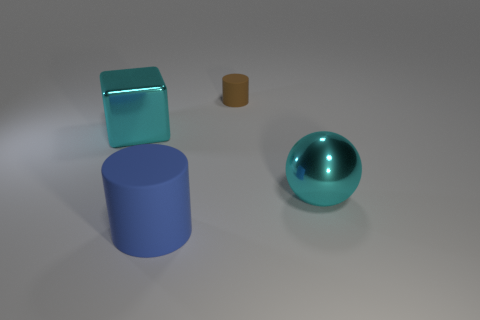Add 3 small green shiny cylinders. How many objects exist? 7 Subtract all balls. How many objects are left? 3 Subtract all red matte blocks. Subtract all big cyan shiny balls. How many objects are left? 3 Add 1 matte objects. How many matte objects are left? 3 Add 3 large brown metal cubes. How many large brown metal cubes exist? 3 Subtract 0 blue balls. How many objects are left? 4 